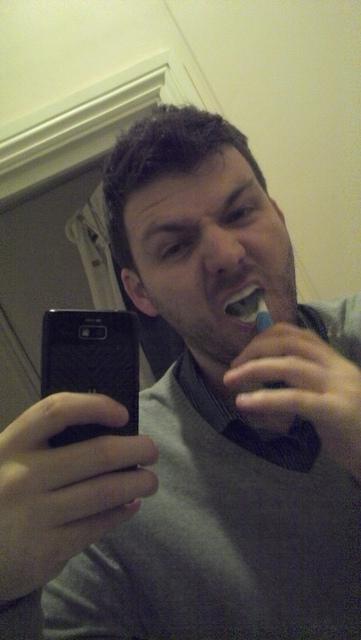How many shirts does this man have on?
Give a very brief answer. 2. How many toothbrushes?
Give a very brief answer. 1. How many cars are in the picture?
Give a very brief answer. 0. 